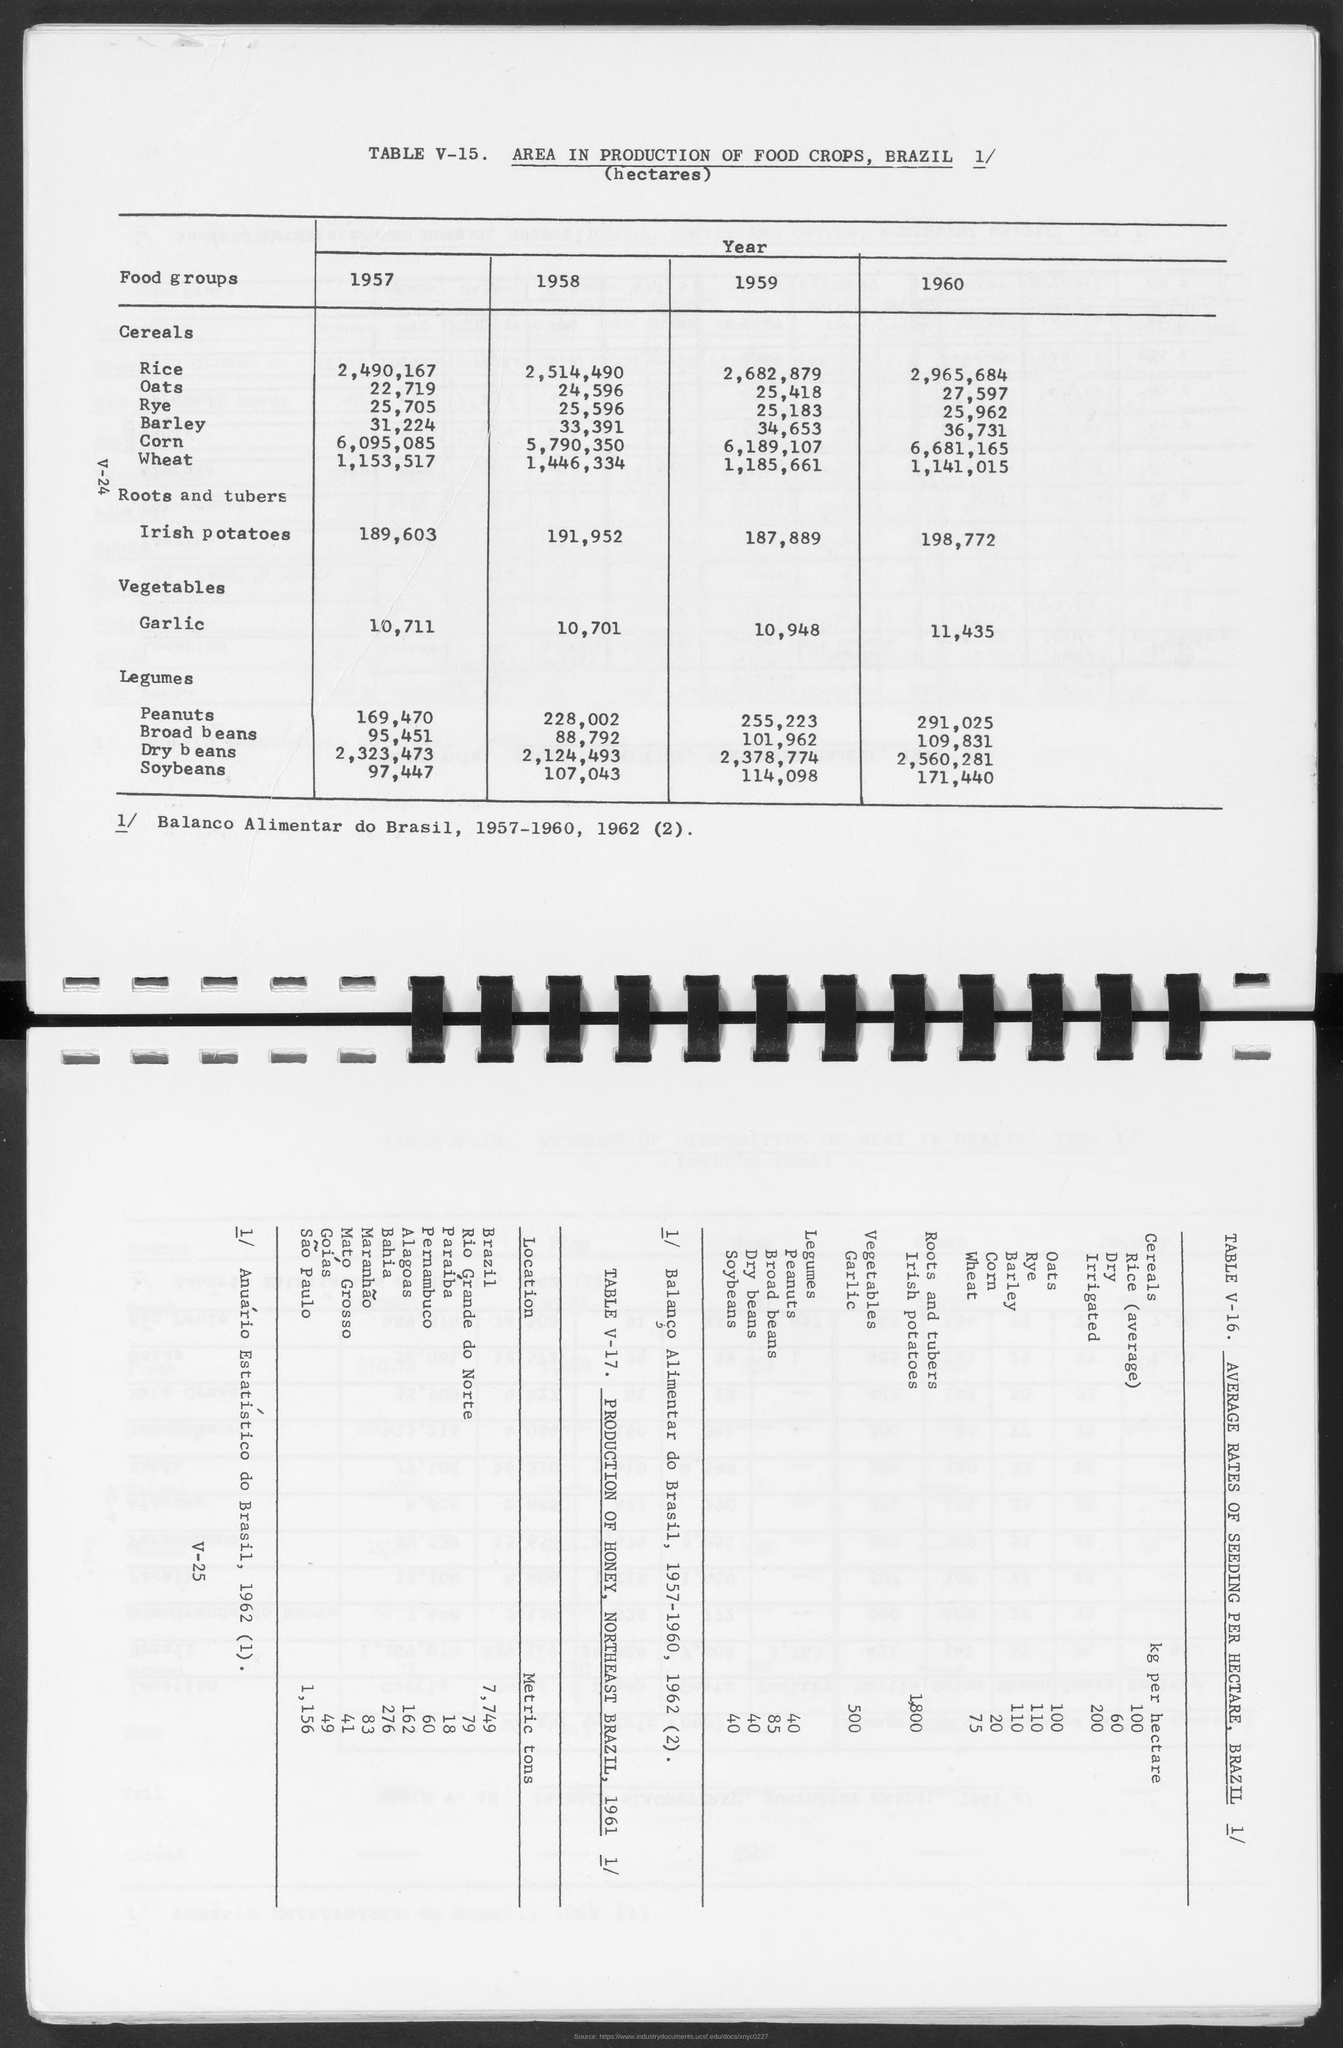How many hectares of Rice in 1958?
Offer a terse response. 2,514,490. How many hectares of Rice in 1959?
Give a very brief answer. 2,682,879. How many hectares of Rice in 1960?
Provide a succinct answer. 2,965,684. How many hectares of Oats in 1957?
Offer a very short reply. 22,719. How many hectares of Oats in 1958?
Your response must be concise. 24,596. How many hectares of Oats in 1959?
Make the answer very short. 25,418. How many hectares of Oats in 1960?
Your response must be concise. 27,597. How many hectares of Rye in 1957?
Provide a short and direct response. 25,705. How many hectares of Rye in 1958?
Keep it short and to the point. 25,596. 